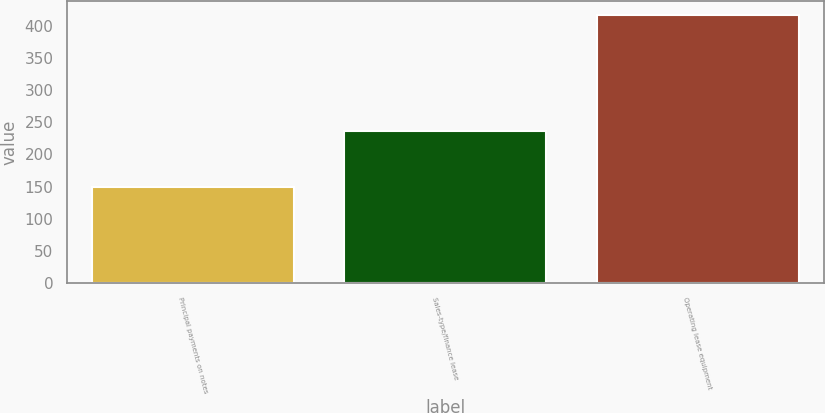Convert chart. <chart><loc_0><loc_0><loc_500><loc_500><bar_chart><fcel>Principal payments on notes<fcel>Sales-type/finance lease<fcel>Operating lease equipment<nl><fcel>149<fcel>236<fcel>417<nl></chart> 